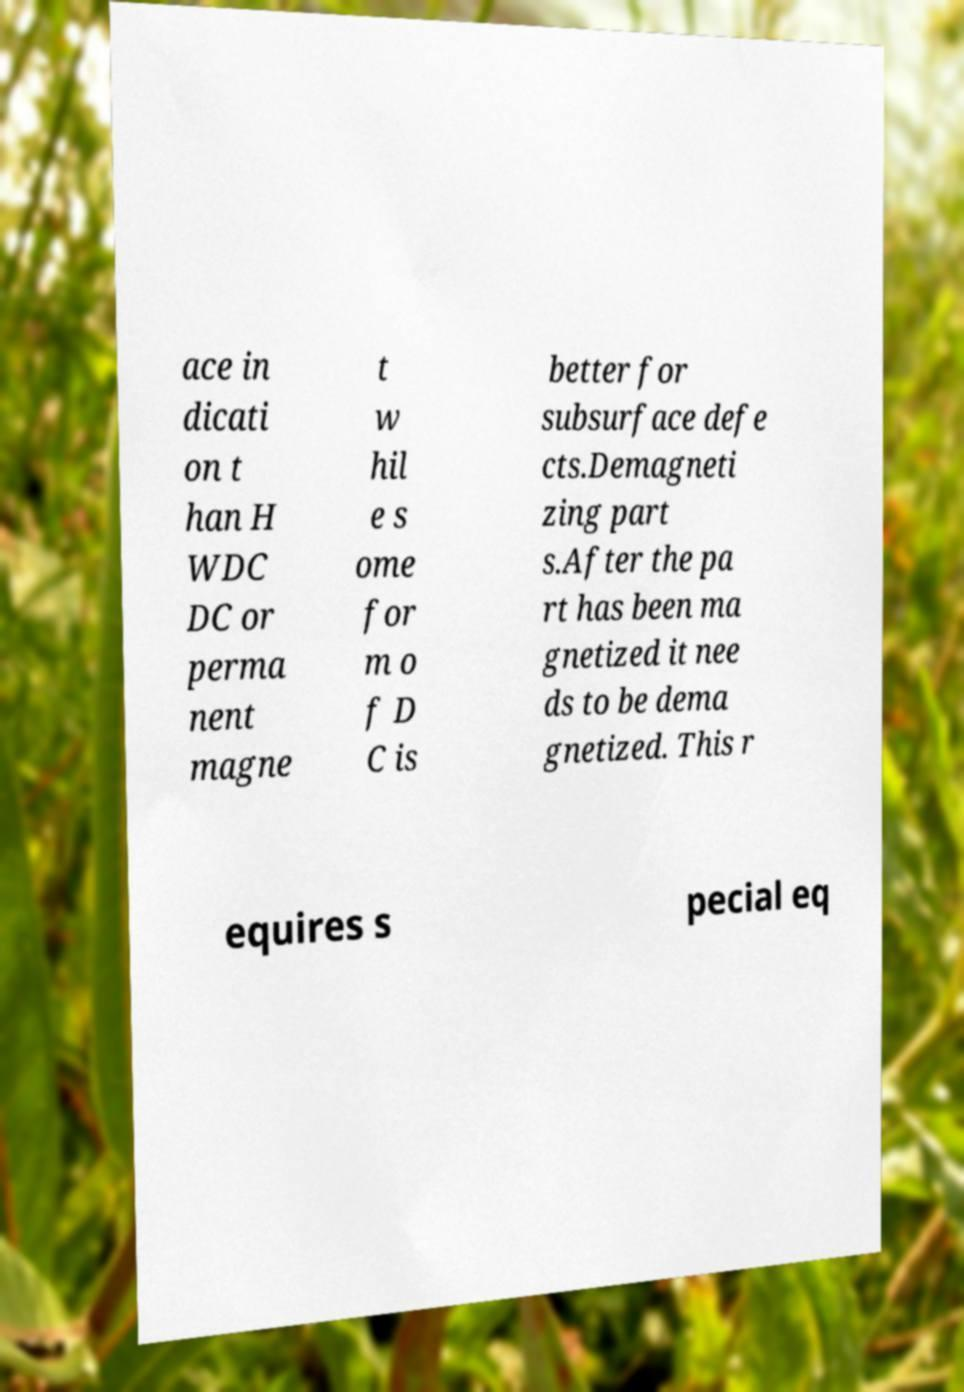Can you read and provide the text displayed in the image?This photo seems to have some interesting text. Can you extract and type it out for me? ace in dicati on t han H WDC DC or perma nent magne t w hil e s ome for m o f D C is better for subsurface defe cts.Demagneti zing part s.After the pa rt has been ma gnetized it nee ds to be dema gnetized. This r equires s pecial eq 